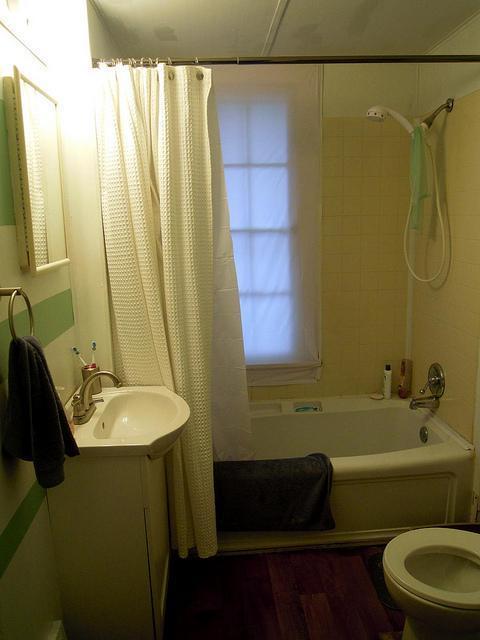How many curtains are there?
Give a very brief answer. 2. How many slices of pizza are left of the fork?
Give a very brief answer. 0. 